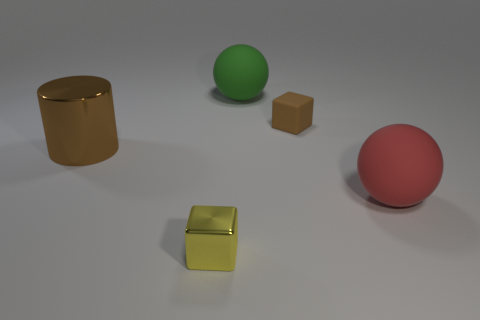There is a thing that is the same color as the rubber block; what is its shape?
Provide a short and direct response. Cylinder. There is a matte object that is the same color as the big shiny object; what is its size?
Keep it short and to the point. Small. Are there fewer green matte objects than large brown shiny blocks?
Make the answer very short. No. There is a rubber object that is behind the large metal thing and in front of the large green matte ball; what size is it?
Offer a very short reply. Small. Is the size of the red sphere the same as the brown metal cylinder?
Offer a very short reply. Yes. Is the color of the big matte object behind the red matte ball the same as the tiny metal cube?
Keep it short and to the point. No. What number of brown rubber things are behind the metal cylinder?
Give a very brief answer. 1. Are there more large purple matte cubes than small cubes?
Your answer should be compact. No. There is a object that is left of the small matte cube and in front of the brown metallic cylinder; what shape is it?
Offer a terse response. Cube. Is there a large red sphere?
Provide a succinct answer. Yes. 